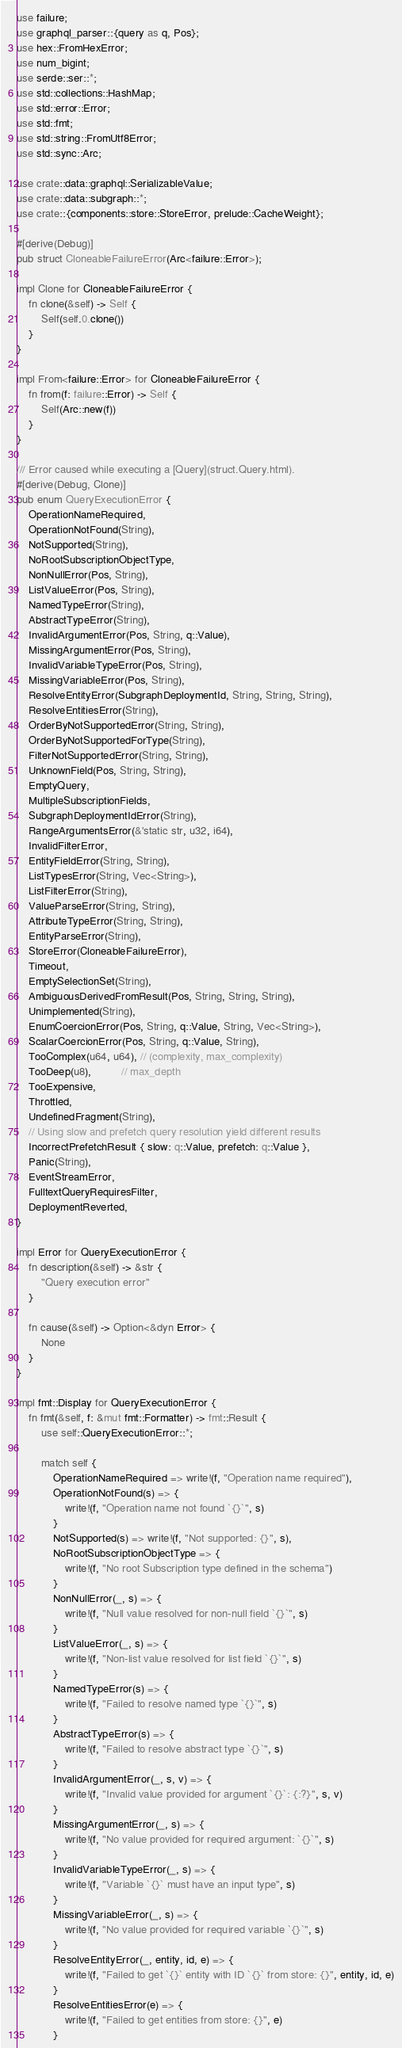<code> <loc_0><loc_0><loc_500><loc_500><_Rust_>use failure;
use graphql_parser::{query as q, Pos};
use hex::FromHexError;
use num_bigint;
use serde::ser::*;
use std::collections::HashMap;
use std::error::Error;
use std::fmt;
use std::string::FromUtf8Error;
use std::sync::Arc;

use crate::data::graphql::SerializableValue;
use crate::data::subgraph::*;
use crate::{components::store::StoreError, prelude::CacheWeight};

#[derive(Debug)]
pub struct CloneableFailureError(Arc<failure::Error>);

impl Clone for CloneableFailureError {
    fn clone(&self) -> Self {
        Self(self.0.clone())
    }
}

impl From<failure::Error> for CloneableFailureError {
    fn from(f: failure::Error) -> Self {
        Self(Arc::new(f))
    }
}

/// Error caused while executing a [Query](struct.Query.html).
#[derive(Debug, Clone)]
pub enum QueryExecutionError {
    OperationNameRequired,
    OperationNotFound(String),
    NotSupported(String),
    NoRootSubscriptionObjectType,
    NonNullError(Pos, String),
    ListValueError(Pos, String),
    NamedTypeError(String),
    AbstractTypeError(String),
    InvalidArgumentError(Pos, String, q::Value),
    MissingArgumentError(Pos, String),
    InvalidVariableTypeError(Pos, String),
    MissingVariableError(Pos, String),
    ResolveEntityError(SubgraphDeploymentId, String, String, String),
    ResolveEntitiesError(String),
    OrderByNotSupportedError(String, String),
    OrderByNotSupportedForType(String),
    FilterNotSupportedError(String, String),
    UnknownField(Pos, String, String),
    EmptyQuery,
    MultipleSubscriptionFields,
    SubgraphDeploymentIdError(String),
    RangeArgumentsError(&'static str, u32, i64),
    InvalidFilterError,
    EntityFieldError(String, String),
    ListTypesError(String, Vec<String>),
    ListFilterError(String),
    ValueParseError(String, String),
    AttributeTypeError(String, String),
    EntityParseError(String),
    StoreError(CloneableFailureError),
    Timeout,
    EmptySelectionSet(String),
    AmbiguousDerivedFromResult(Pos, String, String, String),
    Unimplemented(String),
    EnumCoercionError(Pos, String, q::Value, String, Vec<String>),
    ScalarCoercionError(Pos, String, q::Value, String),
    TooComplex(u64, u64), // (complexity, max_complexity)
    TooDeep(u8),          // max_depth
    TooExpensive,
    Throttled,
    UndefinedFragment(String),
    // Using slow and prefetch query resolution yield different results
    IncorrectPrefetchResult { slow: q::Value, prefetch: q::Value },
    Panic(String),
    EventStreamError,
    FulltextQueryRequiresFilter,
    DeploymentReverted,
}

impl Error for QueryExecutionError {
    fn description(&self) -> &str {
        "Query execution error"
    }

    fn cause(&self) -> Option<&dyn Error> {
        None
    }
}

impl fmt::Display for QueryExecutionError {
    fn fmt(&self, f: &mut fmt::Formatter) -> fmt::Result {
        use self::QueryExecutionError::*;

        match self {
            OperationNameRequired => write!(f, "Operation name required"),
            OperationNotFound(s) => {
                write!(f, "Operation name not found `{}`", s)
            }
            NotSupported(s) => write!(f, "Not supported: {}", s),
            NoRootSubscriptionObjectType => {
                write!(f, "No root Subscription type defined in the schema")
            }
            NonNullError(_, s) => {
                write!(f, "Null value resolved for non-null field `{}`", s)
            }
            ListValueError(_, s) => {
                write!(f, "Non-list value resolved for list field `{}`", s)
            }
            NamedTypeError(s) => {
                write!(f, "Failed to resolve named type `{}`", s)
            }
            AbstractTypeError(s) => {
                write!(f, "Failed to resolve abstract type `{}`", s)
            }
            InvalidArgumentError(_, s, v) => {
                write!(f, "Invalid value provided for argument `{}`: {:?}", s, v)
            }
            MissingArgumentError(_, s) => {
                write!(f, "No value provided for required argument: `{}`", s)
            }
            InvalidVariableTypeError(_, s) => {
                write!(f, "Variable `{}` must have an input type", s)
            }
            MissingVariableError(_, s) => {
                write!(f, "No value provided for required variable `{}`", s)
            }
            ResolveEntityError(_, entity, id, e) => {
                write!(f, "Failed to get `{}` entity with ID `{}` from store: {}", entity, id, e)
            }
            ResolveEntitiesError(e) => {
                write!(f, "Failed to get entities from store: {}", e)
            }</code> 